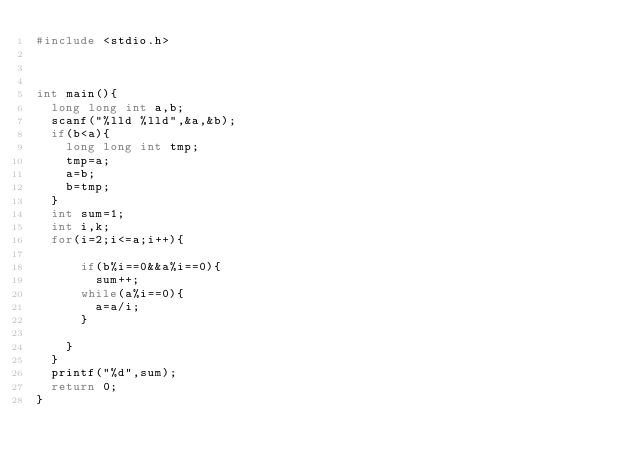Convert code to text. <code><loc_0><loc_0><loc_500><loc_500><_C_>#include <stdio.h>



int main(){
  long long int a,b;
  scanf("%lld %lld",&a,&b);
  if(b<a){
    long long int tmp;
    tmp=a;
    a=b;
    b=tmp;
  }
  int sum=1;
  int i,k;
  for(i=2;i<=a;i++){

      if(b%i==0&&a%i==0){
        sum++;
      while(a%i==0){
        a=a/i;
      }

    }
  }
  printf("%d",sum);
  return 0;
}
</code> 